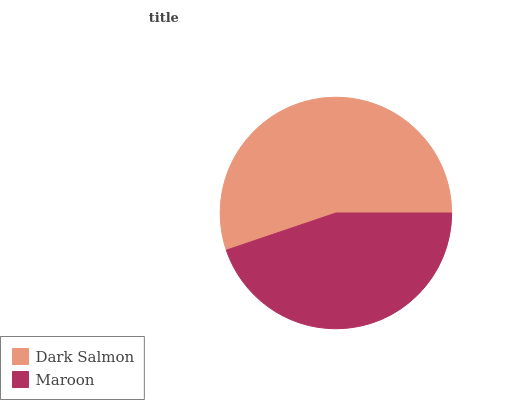Is Maroon the minimum?
Answer yes or no. Yes. Is Dark Salmon the maximum?
Answer yes or no. Yes. Is Maroon the maximum?
Answer yes or no. No. Is Dark Salmon greater than Maroon?
Answer yes or no. Yes. Is Maroon less than Dark Salmon?
Answer yes or no. Yes. Is Maroon greater than Dark Salmon?
Answer yes or no. No. Is Dark Salmon less than Maroon?
Answer yes or no. No. Is Dark Salmon the high median?
Answer yes or no. Yes. Is Maroon the low median?
Answer yes or no. Yes. Is Maroon the high median?
Answer yes or no. No. Is Dark Salmon the low median?
Answer yes or no. No. 